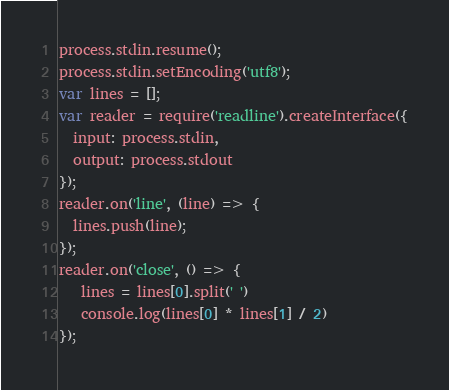Convert code to text. <code><loc_0><loc_0><loc_500><loc_500><_JavaScript_>process.stdin.resume();
process.stdin.setEncoding('utf8');
var lines = [];
var reader = require('readline').createInterface({
  input: process.stdin,
  output: process.stdout
});
reader.on('line', (line) => {
  lines.push(line);
});
reader.on('close', () => {
   lines = lines[0].split(' ')
   console.log(lines[0] * lines[1] / 2)
});</code> 